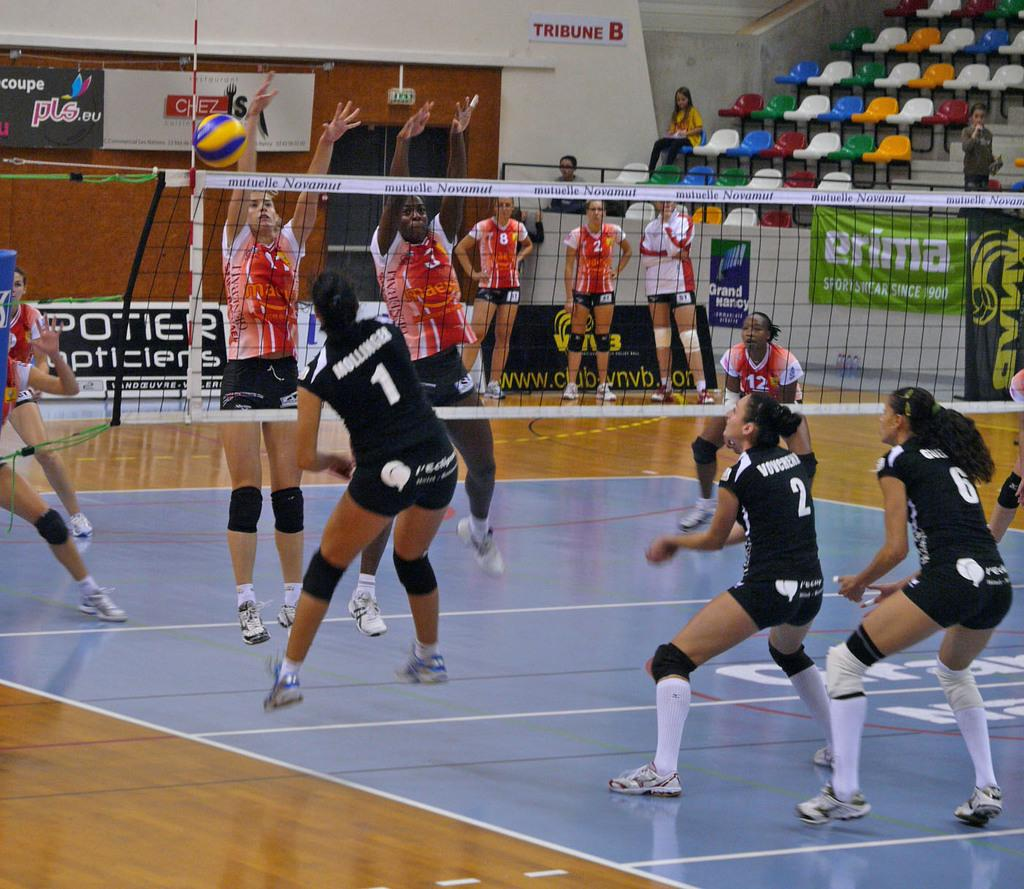<image>
Relay a brief, clear account of the picture shown. a volleyball game with one girl wearing the number 1 jersey 